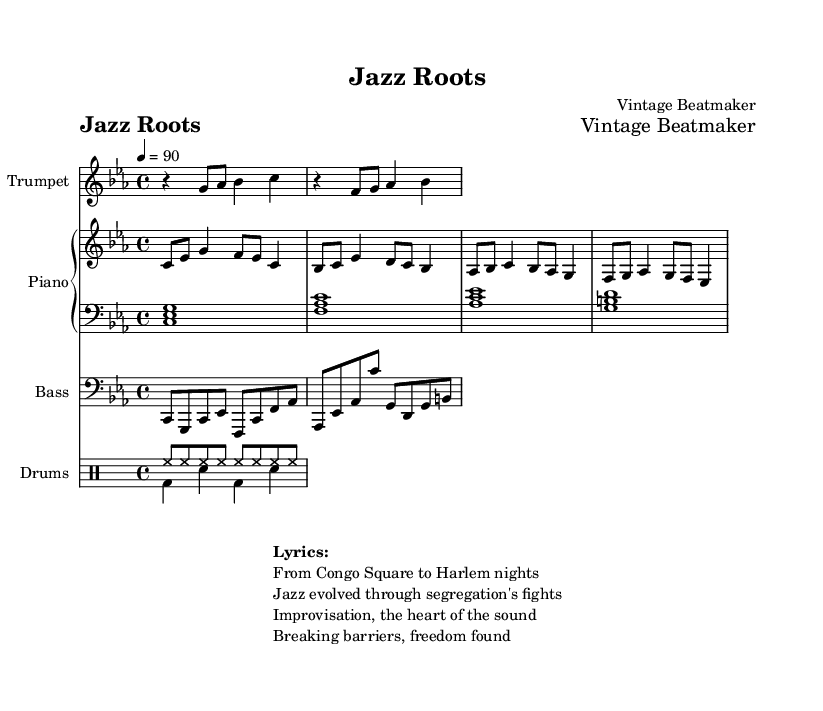What is the key signature of this music? The key signature is indicated as C minor, showing three flats (B♭, E♭, A♭). This is confirmed by the presence of B♭ in the music and the overall tonality suggested by the notes played.
Answer: C minor What is the time signature of this piece? The time signature is written as 4/4, which means there are four beats in each measure and a quarter note gets the beat. This can be seen at the beginning of the score, where the time signature is indicated.
Answer: 4/4 What is the tempo marking for this piece? The tempo marking shows '4 = 90,' meaning the piece should be played at 90 beats per minute, with the quarter note receiving one beat. This is also noted at the beginning of the score.
Answer: 90 How many measures are shown in the trumpet part? The trumpet part contains four measures, which can be counted by looking at the segmented notation within the staff for the trumpet instrument. Each vertical line indicates a new measure.
Answer: Four What is the significance of improvisation in this hip-hop piece? Improvisation is indicated as the "heart of the sound" in the lyrics, reflecting its importance in jazz culture and history. This connection is crucial as hip-hop culture often draws from jazz's improvisational aspects, highlighting creativity and expression in the flow of music.
Answer: Heart of the sound What instrument plays the bass line in this piece? The bass line is explicitly indicated to be played by the instrument labeled "Bass." This is supported by the unique staff setup in the scored music, where the clef and instrument name confirm this.
Answer: Bass What period of jazz history is referenced in the lyrics of the song? The lyrics mention "Congo Square" and "Harlem nights," referencing the historical places that were significant in the evolution of jazz culture, particularly emphasizing the African American experience and jazz's roots through social struggles.
Answer: Congo Square to Harlem nights 